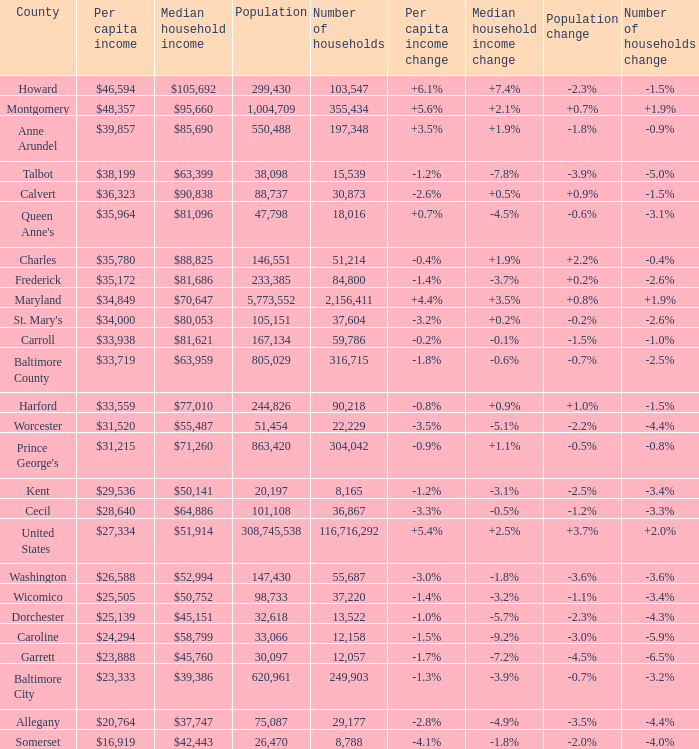What is the per capital income for Washington county? $26,588. 